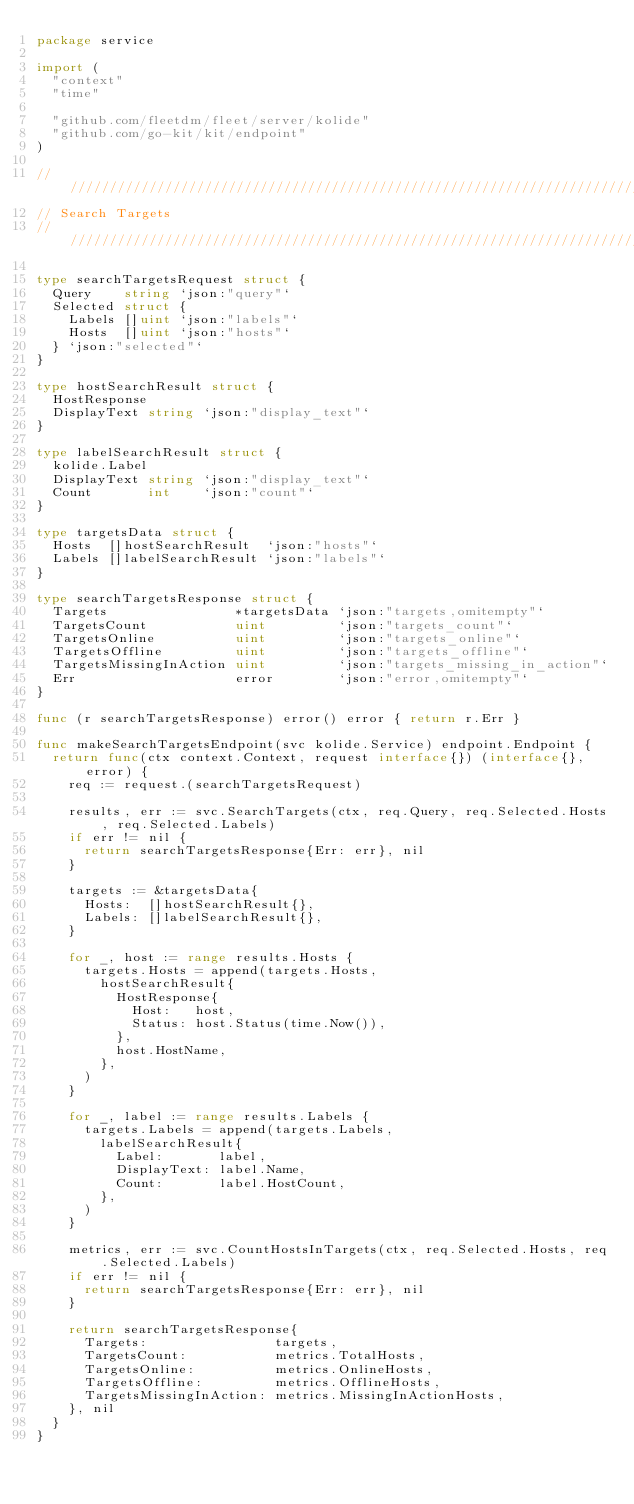Convert code to text. <code><loc_0><loc_0><loc_500><loc_500><_Go_>package service

import (
	"context"
	"time"

	"github.com/fleetdm/fleet/server/kolide"
	"github.com/go-kit/kit/endpoint"
)

////////////////////////////////////////////////////////////////////////////////
// Search Targets
////////////////////////////////////////////////////////////////////////////////

type searchTargetsRequest struct {
	Query    string `json:"query"`
	Selected struct {
		Labels []uint `json:"labels"`
		Hosts  []uint `json:"hosts"`
	} `json:"selected"`
}

type hostSearchResult struct {
	HostResponse
	DisplayText string `json:"display_text"`
}

type labelSearchResult struct {
	kolide.Label
	DisplayText string `json:"display_text"`
	Count       int    `json:"count"`
}

type targetsData struct {
	Hosts  []hostSearchResult  `json:"hosts"`
	Labels []labelSearchResult `json:"labels"`
}

type searchTargetsResponse struct {
	Targets                *targetsData `json:"targets,omitempty"`
	TargetsCount           uint         `json:"targets_count"`
	TargetsOnline          uint         `json:"targets_online"`
	TargetsOffline         uint         `json:"targets_offline"`
	TargetsMissingInAction uint         `json:"targets_missing_in_action"`
	Err                    error        `json:"error,omitempty"`
}

func (r searchTargetsResponse) error() error { return r.Err }

func makeSearchTargetsEndpoint(svc kolide.Service) endpoint.Endpoint {
	return func(ctx context.Context, request interface{}) (interface{}, error) {
		req := request.(searchTargetsRequest)

		results, err := svc.SearchTargets(ctx, req.Query, req.Selected.Hosts, req.Selected.Labels)
		if err != nil {
			return searchTargetsResponse{Err: err}, nil
		}

		targets := &targetsData{
			Hosts:  []hostSearchResult{},
			Labels: []labelSearchResult{},
		}

		for _, host := range results.Hosts {
			targets.Hosts = append(targets.Hosts,
				hostSearchResult{
					HostResponse{
						Host:   host,
						Status: host.Status(time.Now()),
					},
					host.HostName,
				},
			)
		}

		for _, label := range results.Labels {
			targets.Labels = append(targets.Labels,
				labelSearchResult{
					Label:       label,
					DisplayText: label.Name,
					Count:       label.HostCount,
				},
			)
		}

		metrics, err := svc.CountHostsInTargets(ctx, req.Selected.Hosts, req.Selected.Labels)
		if err != nil {
			return searchTargetsResponse{Err: err}, nil
		}

		return searchTargetsResponse{
			Targets:                targets,
			TargetsCount:           metrics.TotalHosts,
			TargetsOnline:          metrics.OnlineHosts,
			TargetsOffline:         metrics.OfflineHosts,
			TargetsMissingInAction: metrics.MissingInActionHosts,
		}, nil
	}
}
</code> 